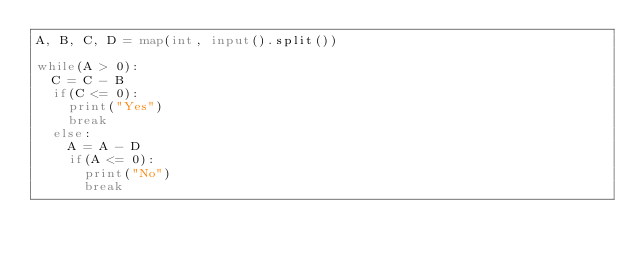<code> <loc_0><loc_0><loc_500><loc_500><_Python_>A, B, C, D = map(int, input().split())

while(A > 0):
  C = C - B
  if(C <= 0):
    print("Yes")
    break
  else:
    A = A - D
    if(A <= 0):
      print("No")
      break</code> 